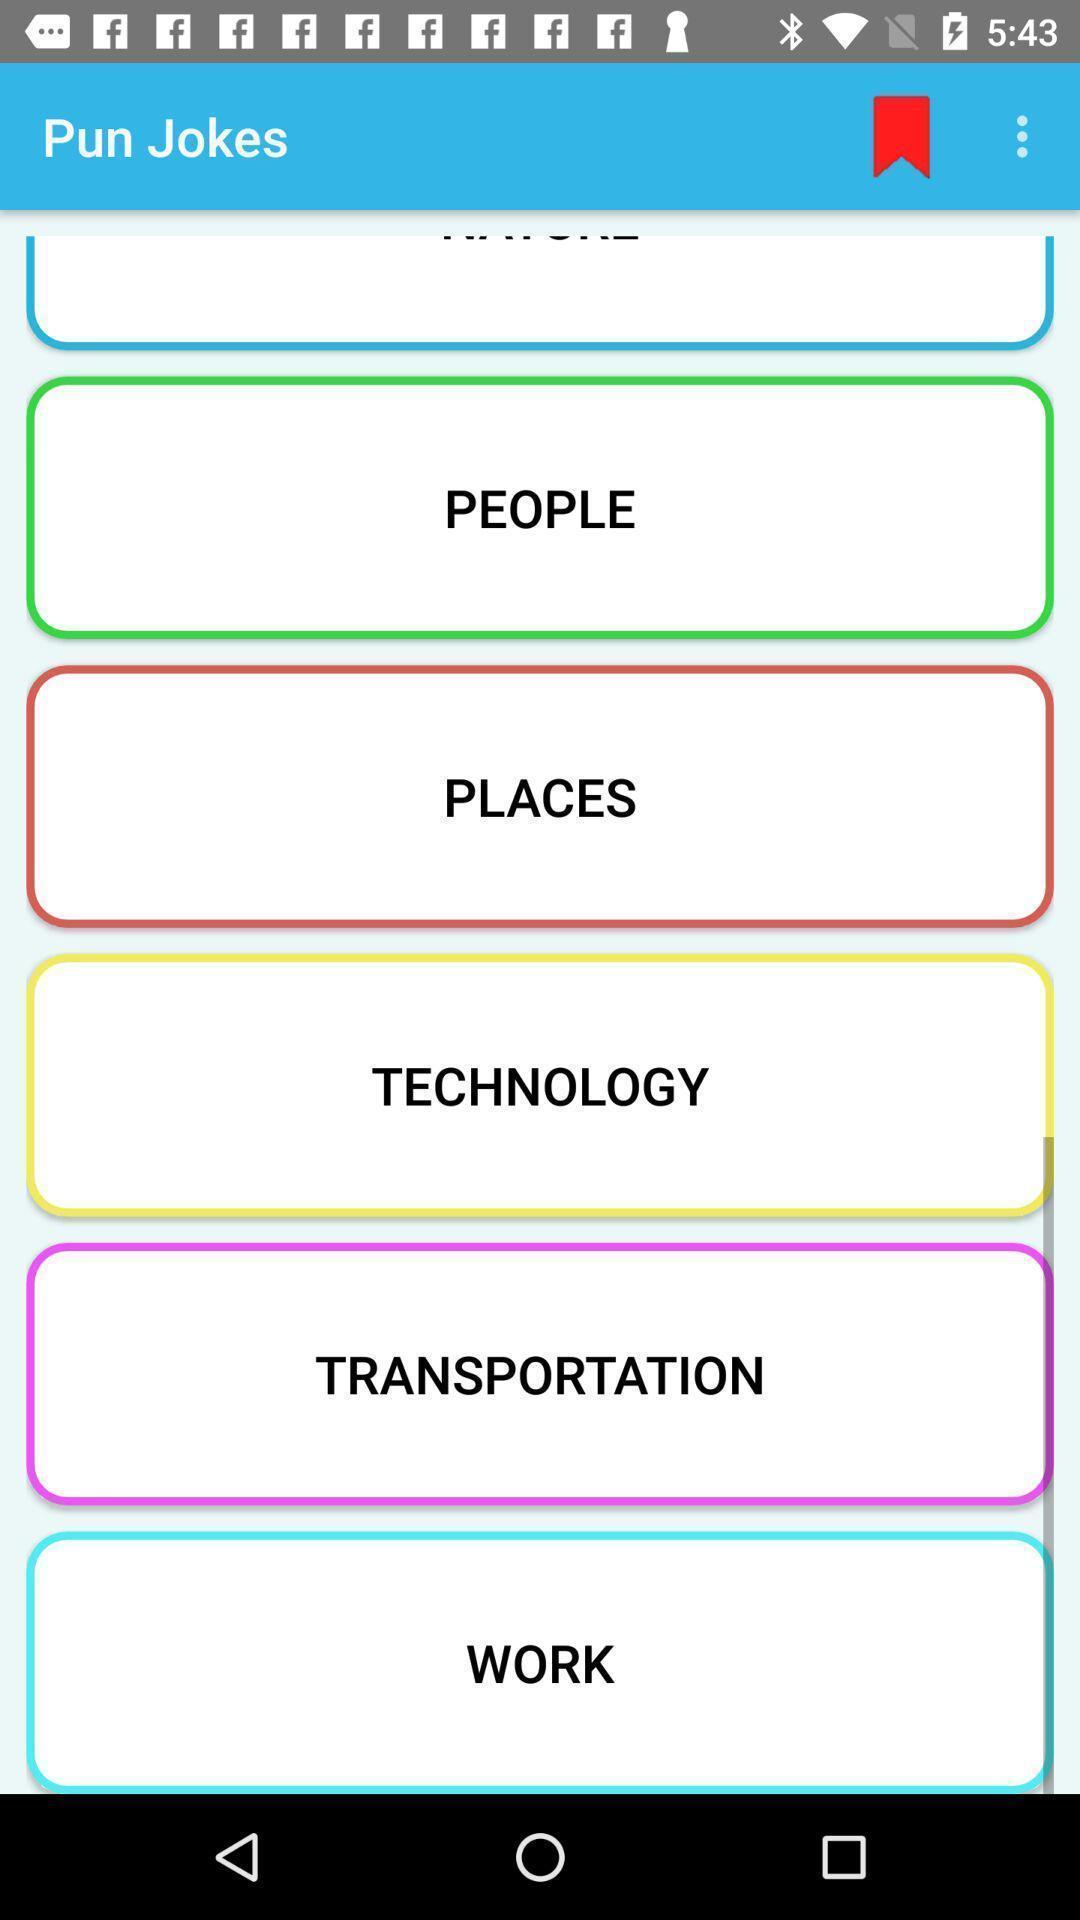Tell me what you see in this picture. Screen displaying options with bookmark. 